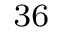Convert formula to latex. <formula><loc_0><loc_0><loc_500><loc_500>_ { 3 6 }</formula> 